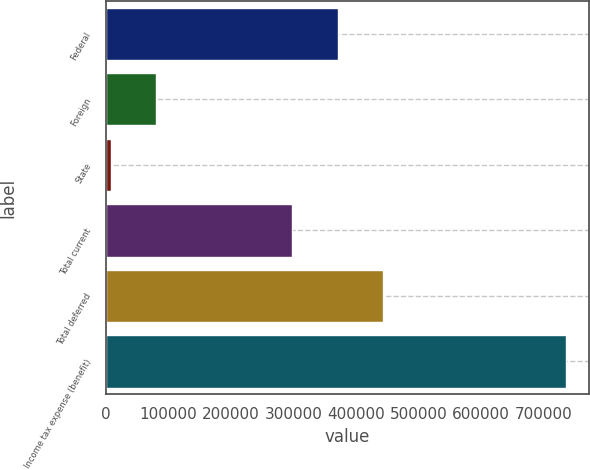<chart> <loc_0><loc_0><loc_500><loc_500><bar_chart><fcel>Federal<fcel>Foreign<fcel>State<fcel>Total current<fcel>Total deferred<fcel>Income tax expense (benefit)<nl><fcel>370868<fcel>80708.6<fcel>7904<fcel>298063<fcel>443672<fcel>735950<nl></chart> 